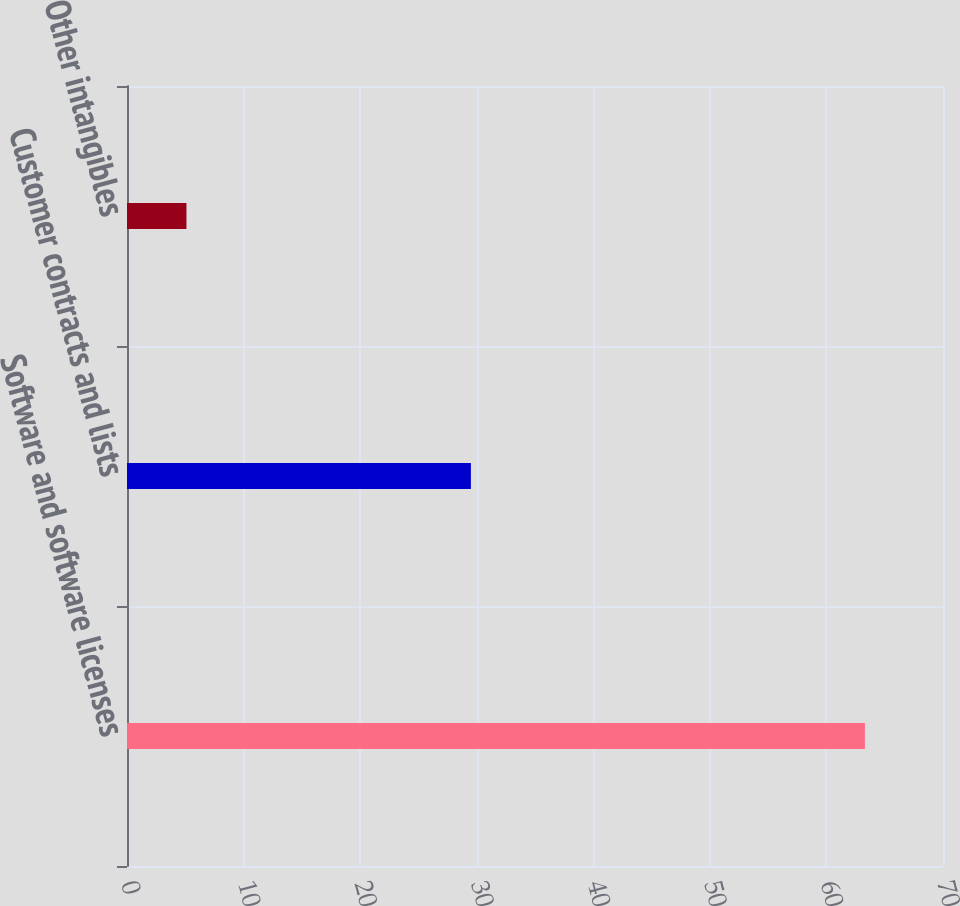Convert chart. <chart><loc_0><loc_0><loc_500><loc_500><bar_chart><fcel>Software and software licenses<fcel>Customer contracts and lists<fcel>Other intangibles<nl><fcel>63.3<fcel>29.5<fcel>5.1<nl></chart> 